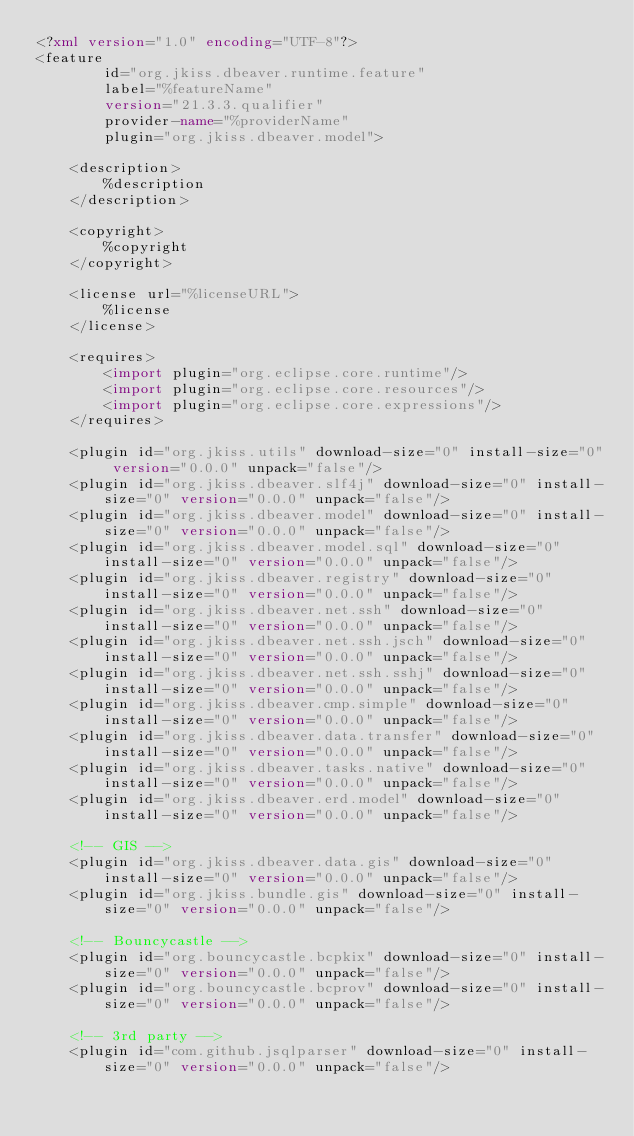<code> <loc_0><loc_0><loc_500><loc_500><_XML_><?xml version="1.0" encoding="UTF-8"?>
<feature
        id="org.jkiss.dbeaver.runtime.feature"
        label="%featureName"
        version="21.3.3.qualifier"
        provider-name="%providerName"
        plugin="org.jkiss.dbeaver.model">

    <description>
        %description
    </description>

    <copyright>
        %copyright
    </copyright>

    <license url="%licenseURL">
        %license
    </license>

    <requires>
        <import plugin="org.eclipse.core.runtime"/>
        <import plugin="org.eclipse.core.resources"/>
        <import plugin="org.eclipse.core.expressions"/>
    </requires>

    <plugin id="org.jkiss.utils" download-size="0" install-size="0" version="0.0.0" unpack="false"/>
    <plugin id="org.jkiss.dbeaver.slf4j" download-size="0" install-size="0" version="0.0.0" unpack="false"/>
    <plugin id="org.jkiss.dbeaver.model" download-size="0" install-size="0" version="0.0.0" unpack="false"/>
    <plugin id="org.jkiss.dbeaver.model.sql" download-size="0" install-size="0" version="0.0.0" unpack="false"/>
    <plugin id="org.jkiss.dbeaver.registry" download-size="0" install-size="0" version="0.0.0" unpack="false"/>
    <plugin id="org.jkiss.dbeaver.net.ssh" download-size="0" install-size="0" version="0.0.0" unpack="false"/>
    <plugin id="org.jkiss.dbeaver.net.ssh.jsch" download-size="0" install-size="0" version="0.0.0" unpack="false"/>
    <plugin id="org.jkiss.dbeaver.net.ssh.sshj" download-size="0" install-size="0" version="0.0.0" unpack="false"/>
    <plugin id="org.jkiss.dbeaver.cmp.simple" download-size="0" install-size="0" version="0.0.0" unpack="false"/>
    <plugin id="org.jkiss.dbeaver.data.transfer" download-size="0" install-size="0" version="0.0.0" unpack="false"/>
    <plugin id="org.jkiss.dbeaver.tasks.native" download-size="0" install-size="0" version="0.0.0" unpack="false"/>
    <plugin id="org.jkiss.dbeaver.erd.model" download-size="0" install-size="0" version="0.0.0" unpack="false"/>

    <!-- GIS -->
    <plugin id="org.jkiss.dbeaver.data.gis" download-size="0" install-size="0" version="0.0.0" unpack="false"/>
    <plugin id="org.jkiss.bundle.gis" download-size="0" install-size="0" version="0.0.0" unpack="false"/>

    <!-- Bouncycastle -->
    <plugin id="org.bouncycastle.bcpkix" download-size="0" install-size="0" version="0.0.0" unpack="false"/>
    <plugin id="org.bouncycastle.bcprov" download-size="0" install-size="0" version="0.0.0" unpack="false"/>

    <!-- 3rd party -->
    <plugin id="com.github.jsqlparser" download-size="0" install-size="0" version="0.0.0" unpack="false"/></code> 